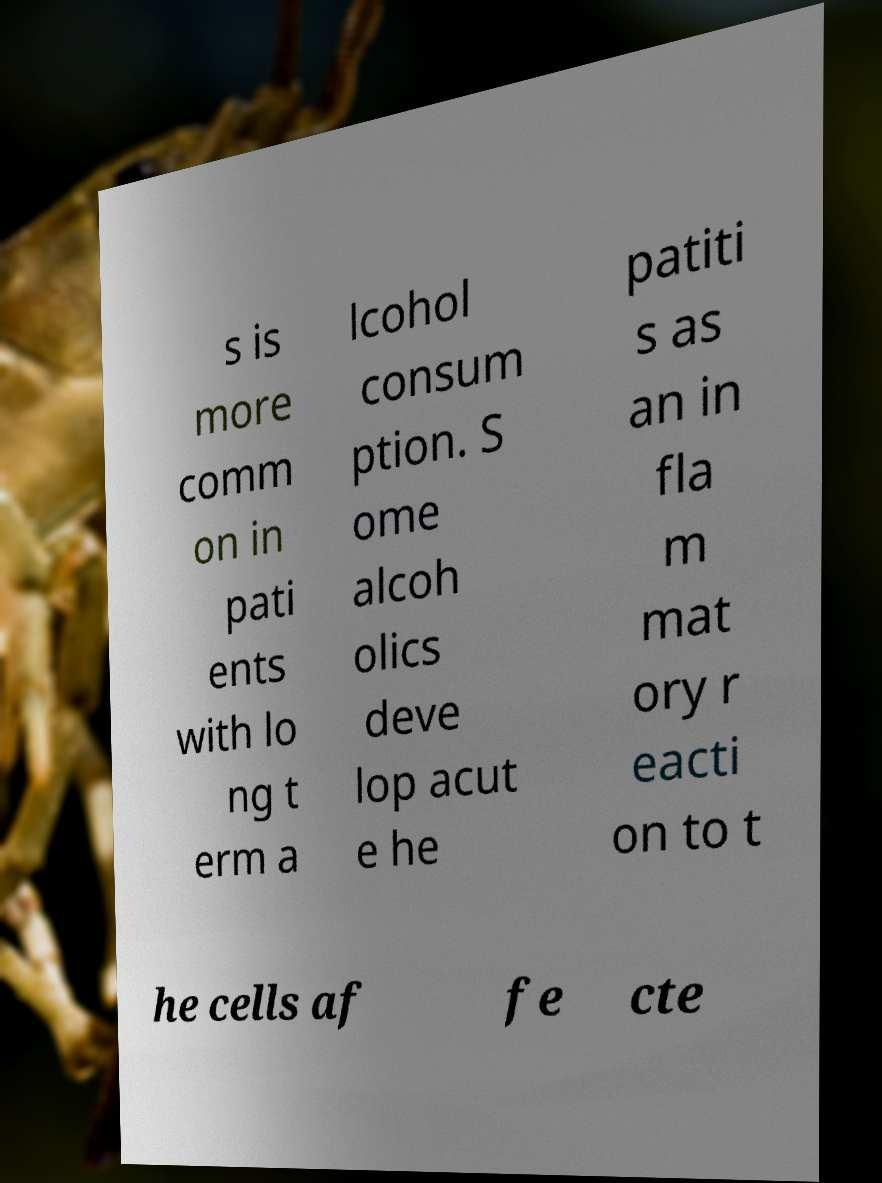Can you accurately transcribe the text from the provided image for me? s is more comm on in pati ents with lo ng t erm a lcohol consum ption. S ome alcoh olics deve lop acut e he patiti s as an in fla m mat ory r eacti on to t he cells af fe cte 